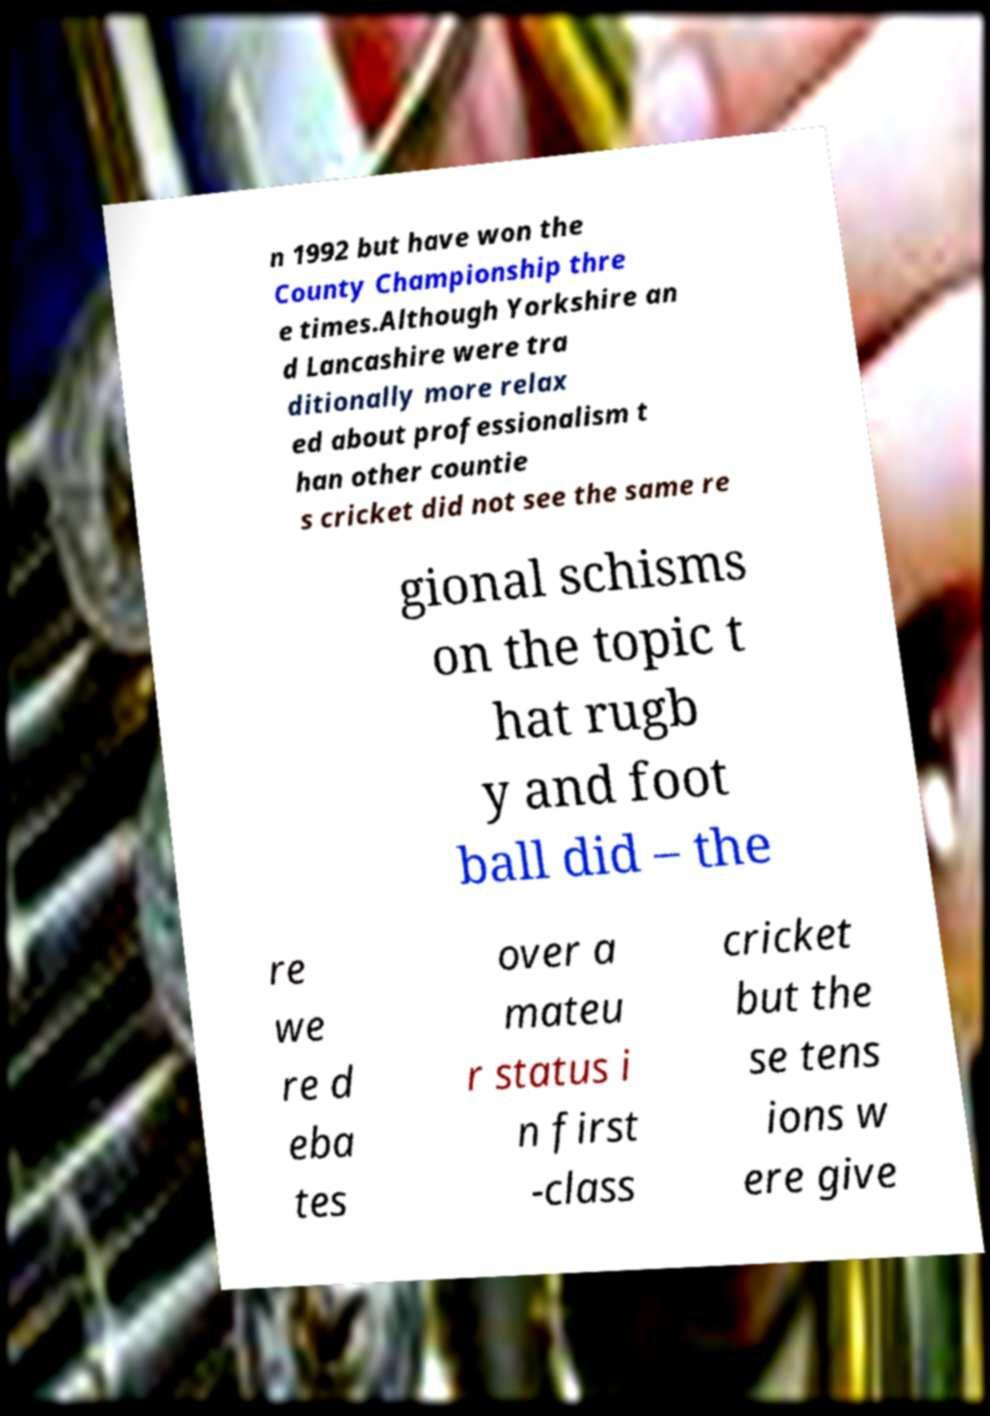What messages or text are displayed in this image? I need them in a readable, typed format. n 1992 but have won the County Championship thre e times.Although Yorkshire an d Lancashire were tra ditionally more relax ed about professionalism t han other countie s cricket did not see the same re gional schisms on the topic t hat rugb y and foot ball did – the re we re d eba tes over a mateu r status i n first -class cricket but the se tens ions w ere give 